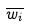<formula> <loc_0><loc_0><loc_500><loc_500>\overline { w _ { i } }</formula> 